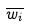<formula> <loc_0><loc_0><loc_500><loc_500>\overline { w _ { i } }</formula> 